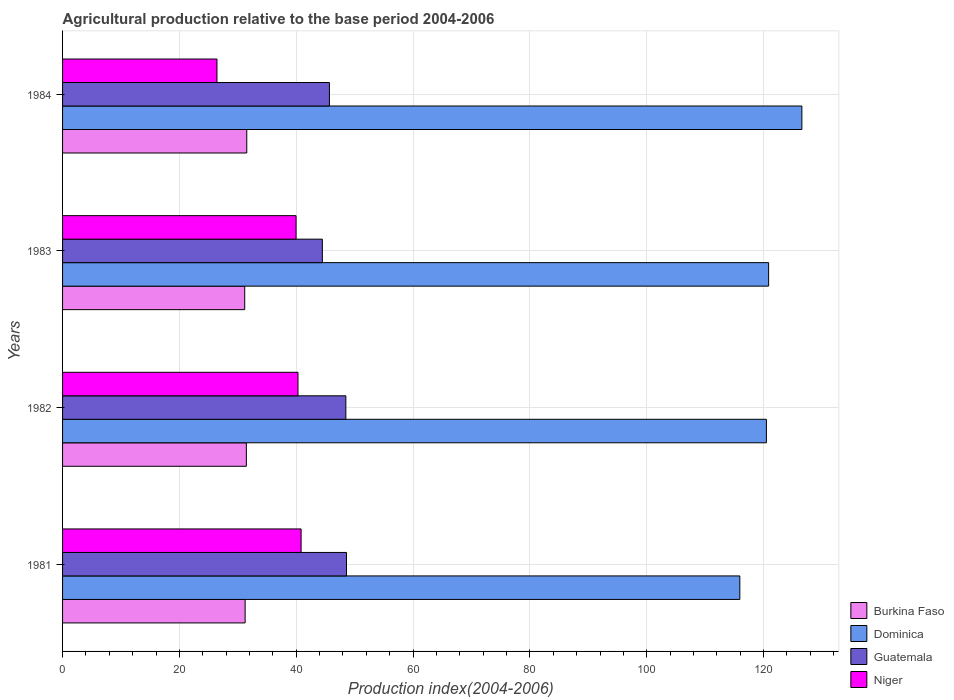How many different coloured bars are there?
Ensure brevity in your answer.  4. How many groups of bars are there?
Ensure brevity in your answer.  4. Are the number of bars on each tick of the Y-axis equal?
Offer a terse response. Yes. How many bars are there on the 3rd tick from the top?
Provide a short and direct response. 4. How many bars are there on the 1st tick from the bottom?
Provide a short and direct response. 4. In how many cases, is the number of bars for a given year not equal to the number of legend labels?
Offer a very short reply. 0. What is the agricultural production index in Niger in 1983?
Your answer should be very brief. 39.97. Across all years, what is the maximum agricultural production index in Dominica?
Ensure brevity in your answer.  126.55. Across all years, what is the minimum agricultural production index in Burkina Faso?
Provide a succinct answer. 31.18. In which year was the agricultural production index in Dominica maximum?
Keep it short and to the point. 1984. In which year was the agricultural production index in Guatemala minimum?
Offer a very short reply. 1983. What is the total agricultural production index in Guatemala in the graph?
Ensure brevity in your answer.  187.24. What is the difference between the agricultural production index in Burkina Faso in 1983 and that in 1984?
Offer a very short reply. -0.35. What is the difference between the agricultural production index in Dominica in 1981 and the agricultural production index in Burkina Faso in 1984?
Your answer should be compact. 84.4. What is the average agricultural production index in Dominica per year?
Your answer should be compact. 120.96. In the year 1984, what is the difference between the agricultural production index in Niger and agricultural production index in Guatemala?
Give a very brief answer. -19.25. What is the ratio of the agricultural production index in Dominica in 1981 to that in 1984?
Your answer should be very brief. 0.92. What is the difference between the highest and the second highest agricultural production index in Burkina Faso?
Make the answer very short. 0.07. What is the difference between the highest and the lowest agricultural production index in Niger?
Provide a succinct answer. 14.4. Is the sum of the agricultural production index in Niger in 1983 and 1984 greater than the maximum agricultural production index in Guatemala across all years?
Keep it short and to the point. Yes. What does the 2nd bar from the top in 1982 represents?
Offer a very short reply. Guatemala. What does the 4th bar from the bottom in 1981 represents?
Make the answer very short. Niger. How many years are there in the graph?
Keep it short and to the point. 4. Where does the legend appear in the graph?
Offer a very short reply. Bottom right. What is the title of the graph?
Offer a very short reply. Agricultural production relative to the base period 2004-2006. Does "Costa Rica" appear as one of the legend labels in the graph?
Your response must be concise. No. What is the label or title of the X-axis?
Provide a succinct answer. Production index(2004-2006). What is the label or title of the Y-axis?
Your response must be concise. Years. What is the Production index(2004-2006) of Burkina Faso in 1981?
Provide a short and direct response. 31.25. What is the Production index(2004-2006) of Dominica in 1981?
Keep it short and to the point. 115.93. What is the Production index(2004-2006) in Guatemala in 1981?
Ensure brevity in your answer.  48.6. What is the Production index(2004-2006) in Niger in 1981?
Make the answer very short. 40.83. What is the Production index(2004-2006) in Burkina Faso in 1982?
Offer a terse response. 31.46. What is the Production index(2004-2006) of Dominica in 1982?
Offer a terse response. 120.48. What is the Production index(2004-2006) of Guatemala in 1982?
Your response must be concise. 48.49. What is the Production index(2004-2006) of Niger in 1982?
Offer a terse response. 40.3. What is the Production index(2004-2006) of Burkina Faso in 1983?
Provide a succinct answer. 31.18. What is the Production index(2004-2006) of Dominica in 1983?
Your answer should be compact. 120.86. What is the Production index(2004-2006) in Guatemala in 1983?
Your answer should be compact. 44.47. What is the Production index(2004-2006) of Niger in 1983?
Your response must be concise. 39.97. What is the Production index(2004-2006) in Burkina Faso in 1984?
Your answer should be compact. 31.53. What is the Production index(2004-2006) in Dominica in 1984?
Keep it short and to the point. 126.55. What is the Production index(2004-2006) in Guatemala in 1984?
Your answer should be very brief. 45.68. What is the Production index(2004-2006) of Niger in 1984?
Offer a terse response. 26.43. Across all years, what is the maximum Production index(2004-2006) of Burkina Faso?
Offer a very short reply. 31.53. Across all years, what is the maximum Production index(2004-2006) of Dominica?
Provide a short and direct response. 126.55. Across all years, what is the maximum Production index(2004-2006) in Guatemala?
Give a very brief answer. 48.6. Across all years, what is the maximum Production index(2004-2006) in Niger?
Your response must be concise. 40.83. Across all years, what is the minimum Production index(2004-2006) in Burkina Faso?
Offer a very short reply. 31.18. Across all years, what is the minimum Production index(2004-2006) of Dominica?
Ensure brevity in your answer.  115.93. Across all years, what is the minimum Production index(2004-2006) of Guatemala?
Provide a short and direct response. 44.47. Across all years, what is the minimum Production index(2004-2006) of Niger?
Provide a succinct answer. 26.43. What is the total Production index(2004-2006) in Burkina Faso in the graph?
Provide a short and direct response. 125.42. What is the total Production index(2004-2006) of Dominica in the graph?
Provide a succinct answer. 483.82. What is the total Production index(2004-2006) of Guatemala in the graph?
Your answer should be compact. 187.24. What is the total Production index(2004-2006) of Niger in the graph?
Keep it short and to the point. 147.53. What is the difference between the Production index(2004-2006) of Burkina Faso in 1981 and that in 1982?
Give a very brief answer. -0.21. What is the difference between the Production index(2004-2006) of Dominica in 1981 and that in 1982?
Offer a terse response. -4.55. What is the difference between the Production index(2004-2006) of Guatemala in 1981 and that in 1982?
Provide a succinct answer. 0.11. What is the difference between the Production index(2004-2006) in Niger in 1981 and that in 1982?
Your answer should be compact. 0.53. What is the difference between the Production index(2004-2006) in Burkina Faso in 1981 and that in 1983?
Offer a very short reply. 0.07. What is the difference between the Production index(2004-2006) of Dominica in 1981 and that in 1983?
Keep it short and to the point. -4.93. What is the difference between the Production index(2004-2006) of Guatemala in 1981 and that in 1983?
Offer a very short reply. 4.13. What is the difference between the Production index(2004-2006) of Niger in 1981 and that in 1983?
Your answer should be very brief. 0.86. What is the difference between the Production index(2004-2006) of Burkina Faso in 1981 and that in 1984?
Your answer should be compact. -0.28. What is the difference between the Production index(2004-2006) of Dominica in 1981 and that in 1984?
Ensure brevity in your answer.  -10.62. What is the difference between the Production index(2004-2006) of Guatemala in 1981 and that in 1984?
Keep it short and to the point. 2.92. What is the difference between the Production index(2004-2006) of Niger in 1981 and that in 1984?
Offer a very short reply. 14.4. What is the difference between the Production index(2004-2006) of Burkina Faso in 1982 and that in 1983?
Keep it short and to the point. 0.28. What is the difference between the Production index(2004-2006) of Dominica in 1982 and that in 1983?
Your response must be concise. -0.38. What is the difference between the Production index(2004-2006) of Guatemala in 1982 and that in 1983?
Ensure brevity in your answer.  4.02. What is the difference between the Production index(2004-2006) in Niger in 1982 and that in 1983?
Keep it short and to the point. 0.33. What is the difference between the Production index(2004-2006) of Burkina Faso in 1982 and that in 1984?
Make the answer very short. -0.07. What is the difference between the Production index(2004-2006) in Dominica in 1982 and that in 1984?
Keep it short and to the point. -6.07. What is the difference between the Production index(2004-2006) of Guatemala in 1982 and that in 1984?
Provide a short and direct response. 2.81. What is the difference between the Production index(2004-2006) in Niger in 1982 and that in 1984?
Your response must be concise. 13.87. What is the difference between the Production index(2004-2006) of Burkina Faso in 1983 and that in 1984?
Make the answer very short. -0.35. What is the difference between the Production index(2004-2006) of Dominica in 1983 and that in 1984?
Give a very brief answer. -5.69. What is the difference between the Production index(2004-2006) of Guatemala in 1983 and that in 1984?
Your answer should be very brief. -1.21. What is the difference between the Production index(2004-2006) in Niger in 1983 and that in 1984?
Offer a terse response. 13.54. What is the difference between the Production index(2004-2006) in Burkina Faso in 1981 and the Production index(2004-2006) in Dominica in 1982?
Keep it short and to the point. -89.23. What is the difference between the Production index(2004-2006) of Burkina Faso in 1981 and the Production index(2004-2006) of Guatemala in 1982?
Give a very brief answer. -17.24. What is the difference between the Production index(2004-2006) in Burkina Faso in 1981 and the Production index(2004-2006) in Niger in 1982?
Offer a terse response. -9.05. What is the difference between the Production index(2004-2006) of Dominica in 1981 and the Production index(2004-2006) of Guatemala in 1982?
Your response must be concise. 67.44. What is the difference between the Production index(2004-2006) in Dominica in 1981 and the Production index(2004-2006) in Niger in 1982?
Your answer should be very brief. 75.63. What is the difference between the Production index(2004-2006) in Guatemala in 1981 and the Production index(2004-2006) in Niger in 1982?
Provide a short and direct response. 8.3. What is the difference between the Production index(2004-2006) of Burkina Faso in 1981 and the Production index(2004-2006) of Dominica in 1983?
Your answer should be compact. -89.61. What is the difference between the Production index(2004-2006) of Burkina Faso in 1981 and the Production index(2004-2006) of Guatemala in 1983?
Offer a terse response. -13.22. What is the difference between the Production index(2004-2006) of Burkina Faso in 1981 and the Production index(2004-2006) of Niger in 1983?
Your answer should be compact. -8.72. What is the difference between the Production index(2004-2006) of Dominica in 1981 and the Production index(2004-2006) of Guatemala in 1983?
Offer a very short reply. 71.46. What is the difference between the Production index(2004-2006) of Dominica in 1981 and the Production index(2004-2006) of Niger in 1983?
Provide a short and direct response. 75.96. What is the difference between the Production index(2004-2006) in Guatemala in 1981 and the Production index(2004-2006) in Niger in 1983?
Your answer should be very brief. 8.63. What is the difference between the Production index(2004-2006) of Burkina Faso in 1981 and the Production index(2004-2006) of Dominica in 1984?
Ensure brevity in your answer.  -95.3. What is the difference between the Production index(2004-2006) in Burkina Faso in 1981 and the Production index(2004-2006) in Guatemala in 1984?
Provide a short and direct response. -14.43. What is the difference between the Production index(2004-2006) in Burkina Faso in 1981 and the Production index(2004-2006) in Niger in 1984?
Provide a short and direct response. 4.82. What is the difference between the Production index(2004-2006) in Dominica in 1981 and the Production index(2004-2006) in Guatemala in 1984?
Give a very brief answer. 70.25. What is the difference between the Production index(2004-2006) in Dominica in 1981 and the Production index(2004-2006) in Niger in 1984?
Offer a terse response. 89.5. What is the difference between the Production index(2004-2006) in Guatemala in 1981 and the Production index(2004-2006) in Niger in 1984?
Give a very brief answer. 22.17. What is the difference between the Production index(2004-2006) in Burkina Faso in 1982 and the Production index(2004-2006) in Dominica in 1983?
Ensure brevity in your answer.  -89.4. What is the difference between the Production index(2004-2006) of Burkina Faso in 1982 and the Production index(2004-2006) of Guatemala in 1983?
Provide a short and direct response. -13.01. What is the difference between the Production index(2004-2006) in Burkina Faso in 1982 and the Production index(2004-2006) in Niger in 1983?
Your answer should be very brief. -8.51. What is the difference between the Production index(2004-2006) in Dominica in 1982 and the Production index(2004-2006) in Guatemala in 1983?
Your answer should be very brief. 76.01. What is the difference between the Production index(2004-2006) of Dominica in 1982 and the Production index(2004-2006) of Niger in 1983?
Offer a very short reply. 80.51. What is the difference between the Production index(2004-2006) of Guatemala in 1982 and the Production index(2004-2006) of Niger in 1983?
Your answer should be very brief. 8.52. What is the difference between the Production index(2004-2006) of Burkina Faso in 1982 and the Production index(2004-2006) of Dominica in 1984?
Offer a very short reply. -95.09. What is the difference between the Production index(2004-2006) of Burkina Faso in 1982 and the Production index(2004-2006) of Guatemala in 1984?
Provide a short and direct response. -14.22. What is the difference between the Production index(2004-2006) in Burkina Faso in 1982 and the Production index(2004-2006) in Niger in 1984?
Provide a short and direct response. 5.03. What is the difference between the Production index(2004-2006) in Dominica in 1982 and the Production index(2004-2006) in Guatemala in 1984?
Your response must be concise. 74.8. What is the difference between the Production index(2004-2006) in Dominica in 1982 and the Production index(2004-2006) in Niger in 1984?
Your response must be concise. 94.05. What is the difference between the Production index(2004-2006) of Guatemala in 1982 and the Production index(2004-2006) of Niger in 1984?
Provide a succinct answer. 22.06. What is the difference between the Production index(2004-2006) in Burkina Faso in 1983 and the Production index(2004-2006) in Dominica in 1984?
Keep it short and to the point. -95.37. What is the difference between the Production index(2004-2006) of Burkina Faso in 1983 and the Production index(2004-2006) of Niger in 1984?
Provide a succinct answer. 4.75. What is the difference between the Production index(2004-2006) in Dominica in 1983 and the Production index(2004-2006) in Guatemala in 1984?
Provide a short and direct response. 75.18. What is the difference between the Production index(2004-2006) in Dominica in 1983 and the Production index(2004-2006) in Niger in 1984?
Your answer should be very brief. 94.43. What is the difference between the Production index(2004-2006) in Guatemala in 1983 and the Production index(2004-2006) in Niger in 1984?
Your answer should be compact. 18.04. What is the average Production index(2004-2006) of Burkina Faso per year?
Make the answer very short. 31.36. What is the average Production index(2004-2006) in Dominica per year?
Ensure brevity in your answer.  120.95. What is the average Production index(2004-2006) in Guatemala per year?
Offer a very short reply. 46.81. What is the average Production index(2004-2006) in Niger per year?
Ensure brevity in your answer.  36.88. In the year 1981, what is the difference between the Production index(2004-2006) of Burkina Faso and Production index(2004-2006) of Dominica?
Give a very brief answer. -84.68. In the year 1981, what is the difference between the Production index(2004-2006) of Burkina Faso and Production index(2004-2006) of Guatemala?
Your answer should be very brief. -17.35. In the year 1981, what is the difference between the Production index(2004-2006) of Burkina Faso and Production index(2004-2006) of Niger?
Provide a short and direct response. -9.58. In the year 1981, what is the difference between the Production index(2004-2006) in Dominica and Production index(2004-2006) in Guatemala?
Your answer should be very brief. 67.33. In the year 1981, what is the difference between the Production index(2004-2006) of Dominica and Production index(2004-2006) of Niger?
Offer a very short reply. 75.1. In the year 1981, what is the difference between the Production index(2004-2006) of Guatemala and Production index(2004-2006) of Niger?
Offer a very short reply. 7.77. In the year 1982, what is the difference between the Production index(2004-2006) of Burkina Faso and Production index(2004-2006) of Dominica?
Make the answer very short. -89.02. In the year 1982, what is the difference between the Production index(2004-2006) in Burkina Faso and Production index(2004-2006) in Guatemala?
Your answer should be very brief. -17.03. In the year 1982, what is the difference between the Production index(2004-2006) in Burkina Faso and Production index(2004-2006) in Niger?
Your response must be concise. -8.84. In the year 1982, what is the difference between the Production index(2004-2006) in Dominica and Production index(2004-2006) in Guatemala?
Provide a succinct answer. 71.99. In the year 1982, what is the difference between the Production index(2004-2006) of Dominica and Production index(2004-2006) of Niger?
Make the answer very short. 80.18. In the year 1982, what is the difference between the Production index(2004-2006) in Guatemala and Production index(2004-2006) in Niger?
Offer a very short reply. 8.19. In the year 1983, what is the difference between the Production index(2004-2006) of Burkina Faso and Production index(2004-2006) of Dominica?
Offer a very short reply. -89.68. In the year 1983, what is the difference between the Production index(2004-2006) of Burkina Faso and Production index(2004-2006) of Guatemala?
Make the answer very short. -13.29. In the year 1983, what is the difference between the Production index(2004-2006) of Burkina Faso and Production index(2004-2006) of Niger?
Offer a terse response. -8.79. In the year 1983, what is the difference between the Production index(2004-2006) of Dominica and Production index(2004-2006) of Guatemala?
Provide a short and direct response. 76.39. In the year 1983, what is the difference between the Production index(2004-2006) in Dominica and Production index(2004-2006) in Niger?
Your answer should be compact. 80.89. In the year 1984, what is the difference between the Production index(2004-2006) of Burkina Faso and Production index(2004-2006) of Dominica?
Give a very brief answer. -95.02. In the year 1984, what is the difference between the Production index(2004-2006) of Burkina Faso and Production index(2004-2006) of Guatemala?
Your response must be concise. -14.15. In the year 1984, what is the difference between the Production index(2004-2006) in Dominica and Production index(2004-2006) in Guatemala?
Offer a very short reply. 80.87. In the year 1984, what is the difference between the Production index(2004-2006) of Dominica and Production index(2004-2006) of Niger?
Give a very brief answer. 100.12. In the year 1984, what is the difference between the Production index(2004-2006) of Guatemala and Production index(2004-2006) of Niger?
Make the answer very short. 19.25. What is the ratio of the Production index(2004-2006) of Dominica in 1981 to that in 1982?
Offer a terse response. 0.96. What is the ratio of the Production index(2004-2006) in Guatemala in 1981 to that in 1982?
Ensure brevity in your answer.  1. What is the ratio of the Production index(2004-2006) of Niger in 1981 to that in 1982?
Give a very brief answer. 1.01. What is the ratio of the Production index(2004-2006) of Dominica in 1981 to that in 1983?
Your answer should be very brief. 0.96. What is the ratio of the Production index(2004-2006) of Guatemala in 1981 to that in 1983?
Offer a very short reply. 1.09. What is the ratio of the Production index(2004-2006) of Niger in 1981 to that in 1983?
Offer a terse response. 1.02. What is the ratio of the Production index(2004-2006) of Burkina Faso in 1981 to that in 1984?
Ensure brevity in your answer.  0.99. What is the ratio of the Production index(2004-2006) in Dominica in 1981 to that in 1984?
Ensure brevity in your answer.  0.92. What is the ratio of the Production index(2004-2006) in Guatemala in 1981 to that in 1984?
Make the answer very short. 1.06. What is the ratio of the Production index(2004-2006) in Niger in 1981 to that in 1984?
Make the answer very short. 1.54. What is the ratio of the Production index(2004-2006) of Guatemala in 1982 to that in 1983?
Your response must be concise. 1.09. What is the ratio of the Production index(2004-2006) in Niger in 1982 to that in 1983?
Your response must be concise. 1.01. What is the ratio of the Production index(2004-2006) in Guatemala in 1982 to that in 1984?
Provide a succinct answer. 1.06. What is the ratio of the Production index(2004-2006) in Niger in 1982 to that in 1984?
Give a very brief answer. 1.52. What is the ratio of the Production index(2004-2006) in Burkina Faso in 1983 to that in 1984?
Your response must be concise. 0.99. What is the ratio of the Production index(2004-2006) in Dominica in 1983 to that in 1984?
Ensure brevity in your answer.  0.95. What is the ratio of the Production index(2004-2006) in Guatemala in 1983 to that in 1984?
Provide a short and direct response. 0.97. What is the ratio of the Production index(2004-2006) in Niger in 1983 to that in 1984?
Offer a terse response. 1.51. What is the difference between the highest and the second highest Production index(2004-2006) of Burkina Faso?
Provide a succinct answer. 0.07. What is the difference between the highest and the second highest Production index(2004-2006) in Dominica?
Provide a short and direct response. 5.69. What is the difference between the highest and the second highest Production index(2004-2006) in Guatemala?
Offer a very short reply. 0.11. What is the difference between the highest and the second highest Production index(2004-2006) in Niger?
Provide a succinct answer. 0.53. What is the difference between the highest and the lowest Production index(2004-2006) of Dominica?
Give a very brief answer. 10.62. What is the difference between the highest and the lowest Production index(2004-2006) in Guatemala?
Your answer should be very brief. 4.13. What is the difference between the highest and the lowest Production index(2004-2006) of Niger?
Offer a very short reply. 14.4. 